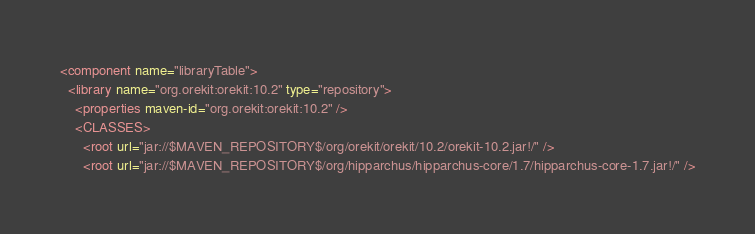Convert code to text. <code><loc_0><loc_0><loc_500><loc_500><_XML_><component name="libraryTable">
  <library name="org.orekit:orekit:10.2" type="repository">
    <properties maven-id="org.orekit:orekit:10.2" />
    <CLASSES>
      <root url="jar://$MAVEN_REPOSITORY$/org/orekit/orekit/10.2/orekit-10.2.jar!/" />
      <root url="jar://$MAVEN_REPOSITORY$/org/hipparchus/hipparchus-core/1.7/hipparchus-core-1.7.jar!/" /></code> 